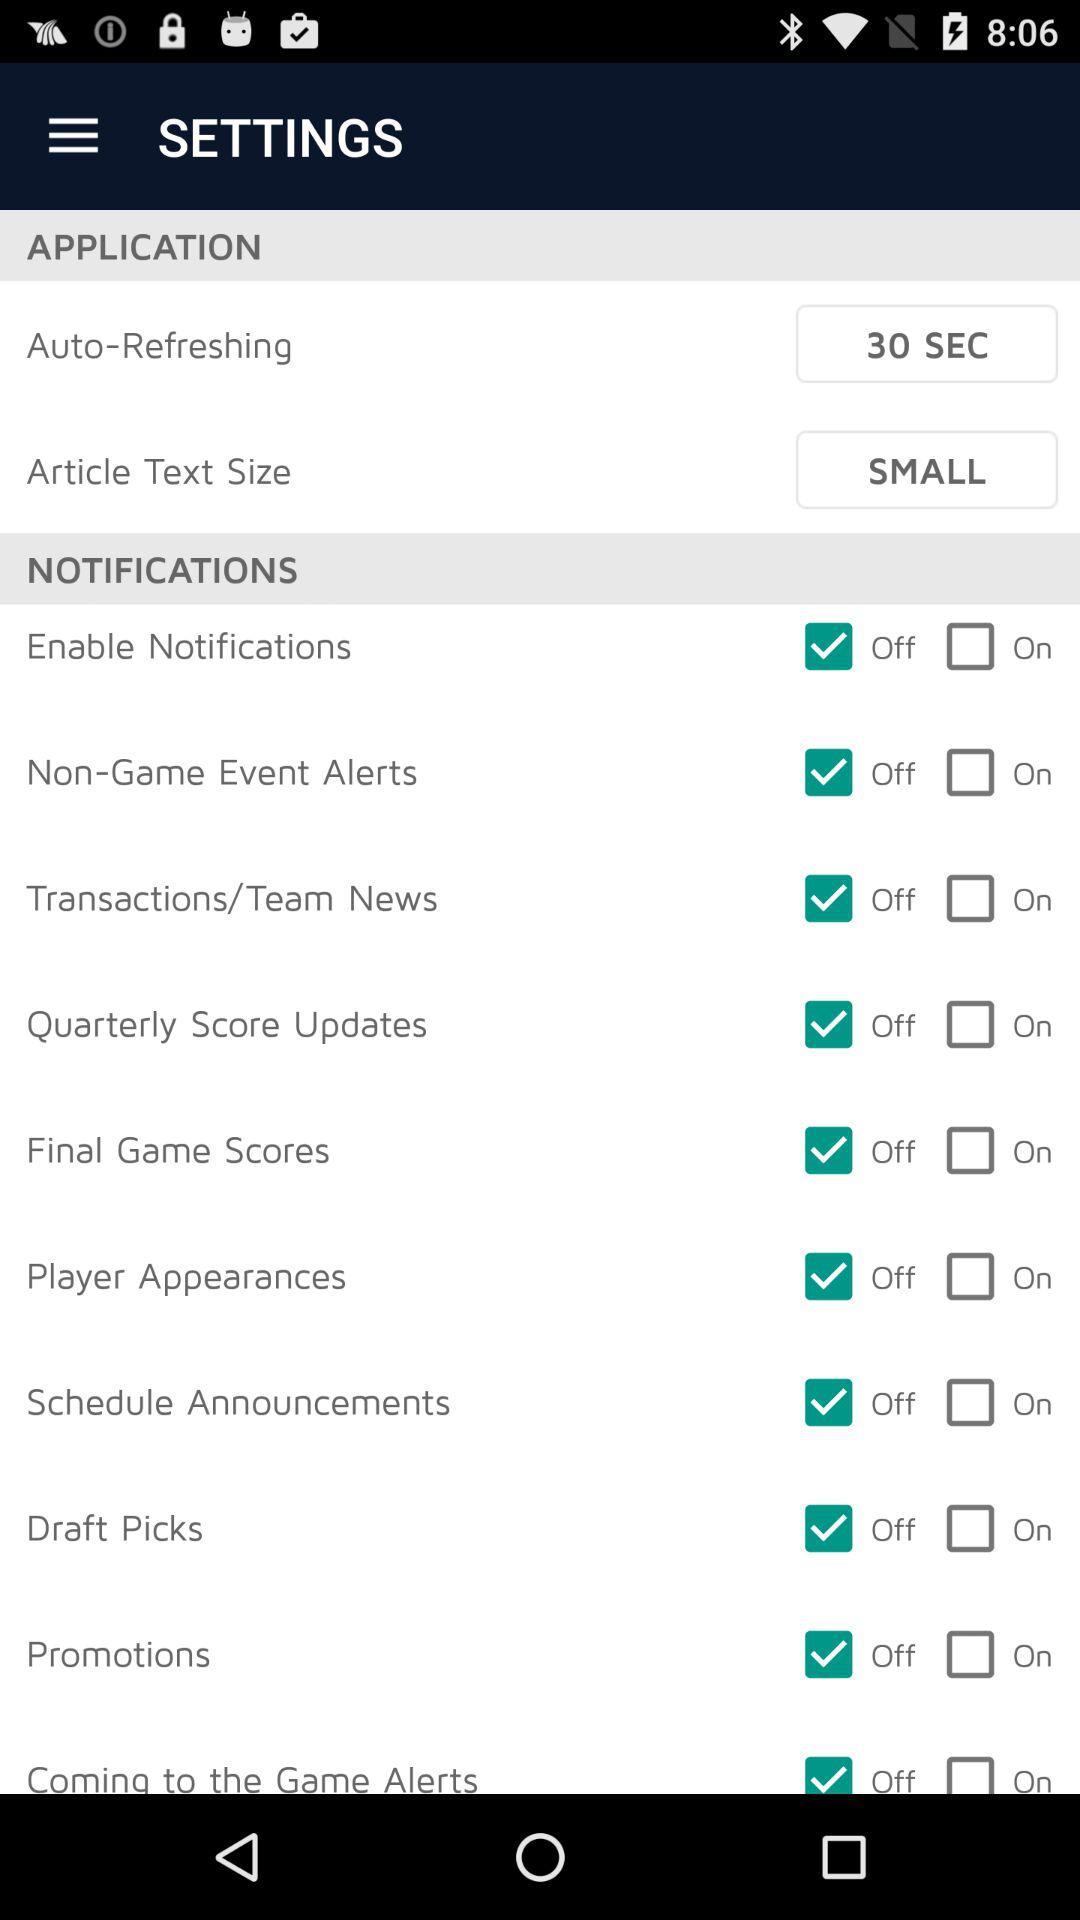What is the status for the "Draft Picks"? The status for the "Draft Picks" is "off". 